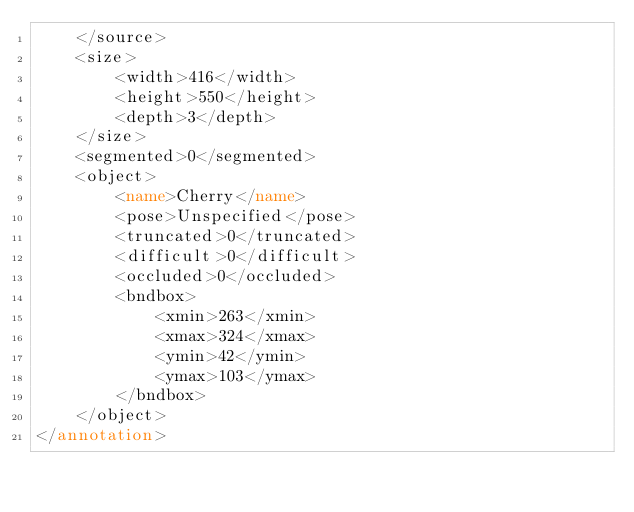Convert code to text. <code><loc_0><loc_0><loc_500><loc_500><_XML_>	</source>
	<size>
		<width>416</width>
		<height>550</height>
		<depth>3</depth>
	</size>
	<segmented>0</segmented>
	<object>
		<name>Cherry</name>
		<pose>Unspecified</pose>
		<truncated>0</truncated>
		<difficult>0</difficult>
		<occluded>0</occluded>
		<bndbox>
			<xmin>263</xmin>
			<xmax>324</xmax>
			<ymin>42</ymin>
			<ymax>103</ymax>
		</bndbox>
	</object>
</annotation>
</code> 